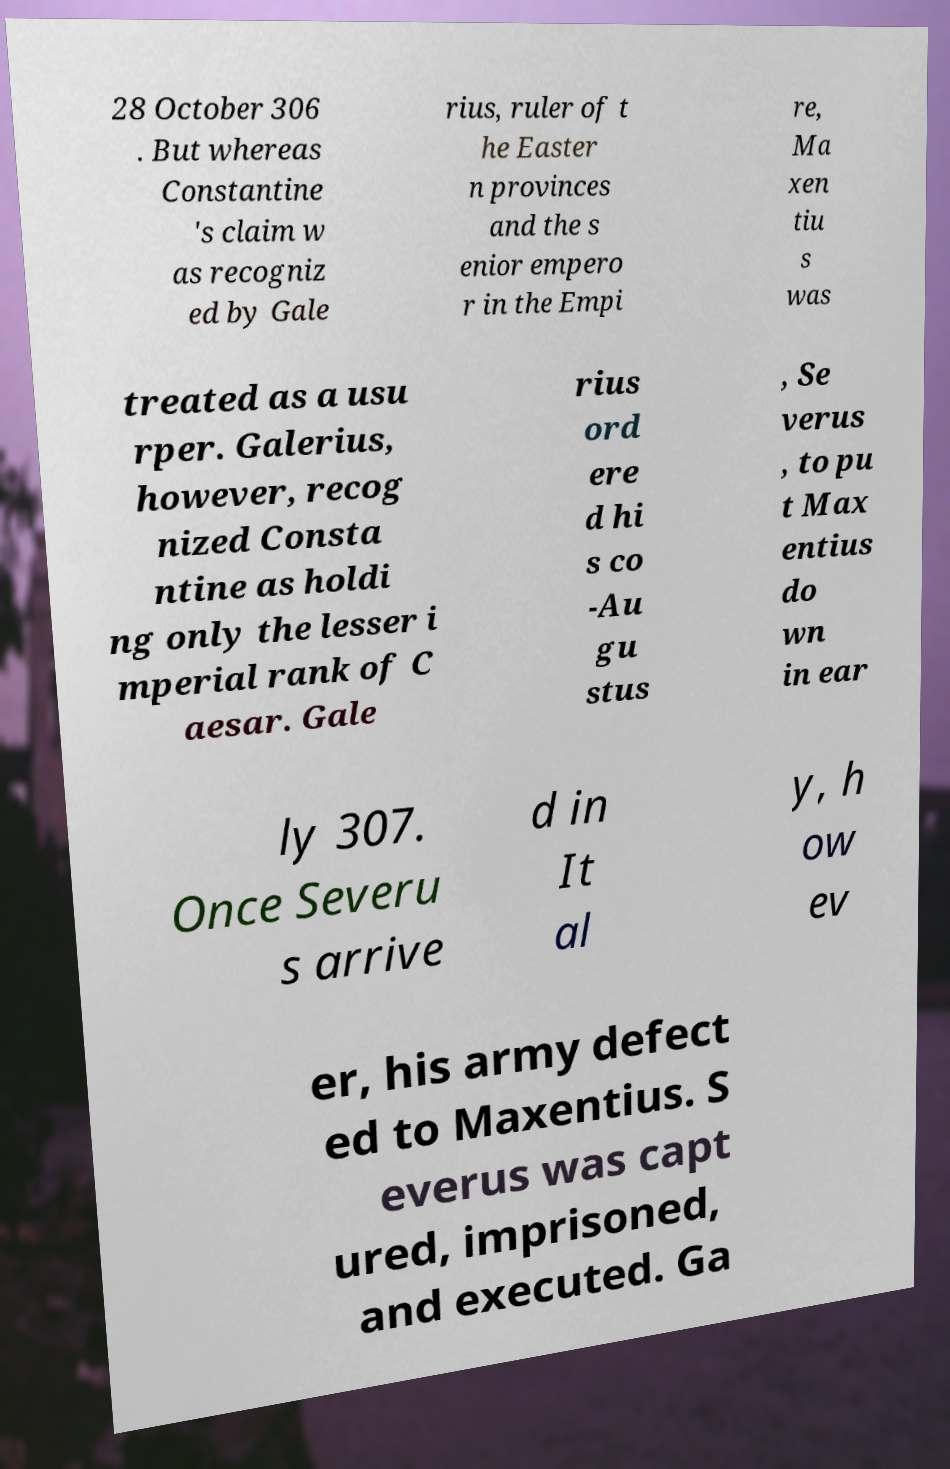Could you extract and type out the text from this image? 28 October 306 . But whereas Constantine 's claim w as recogniz ed by Gale rius, ruler of t he Easter n provinces and the s enior empero r in the Empi re, Ma xen tiu s was treated as a usu rper. Galerius, however, recog nized Consta ntine as holdi ng only the lesser i mperial rank of C aesar. Gale rius ord ere d hi s co -Au gu stus , Se verus , to pu t Max entius do wn in ear ly 307. Once Severu s arrive d in It al y, h ow ev er, his army defect ed to Maxentius. S everus was capt ured, imprisoned, and executed. Ga 